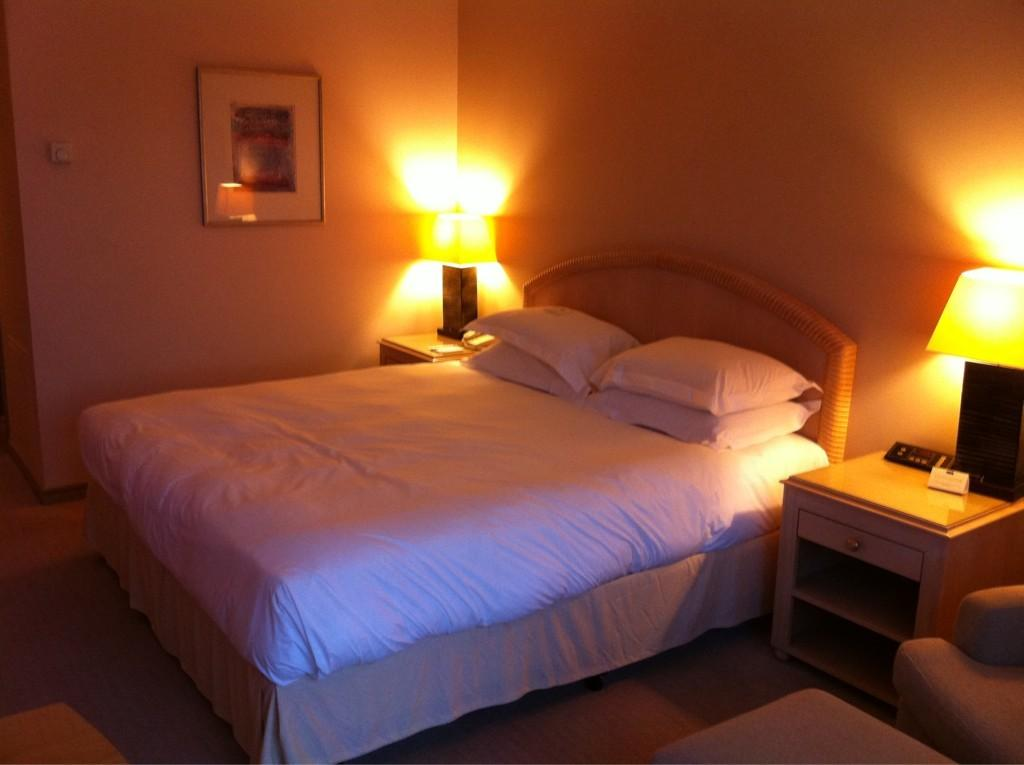What type of furniture is present in the image? There is a bed in the image. What is placed on the bed? There are pillows on the bed. What can be seen on either side of the bed? There are lights or lamps placed on either side of the bed. What is hanging on the wall in the image? There is a portrait on the wall. What type of tank is visible in the image? There is no tank present in the image. What idea is being discussed in the image? The image does not depict a discussion or an idea being presented. 